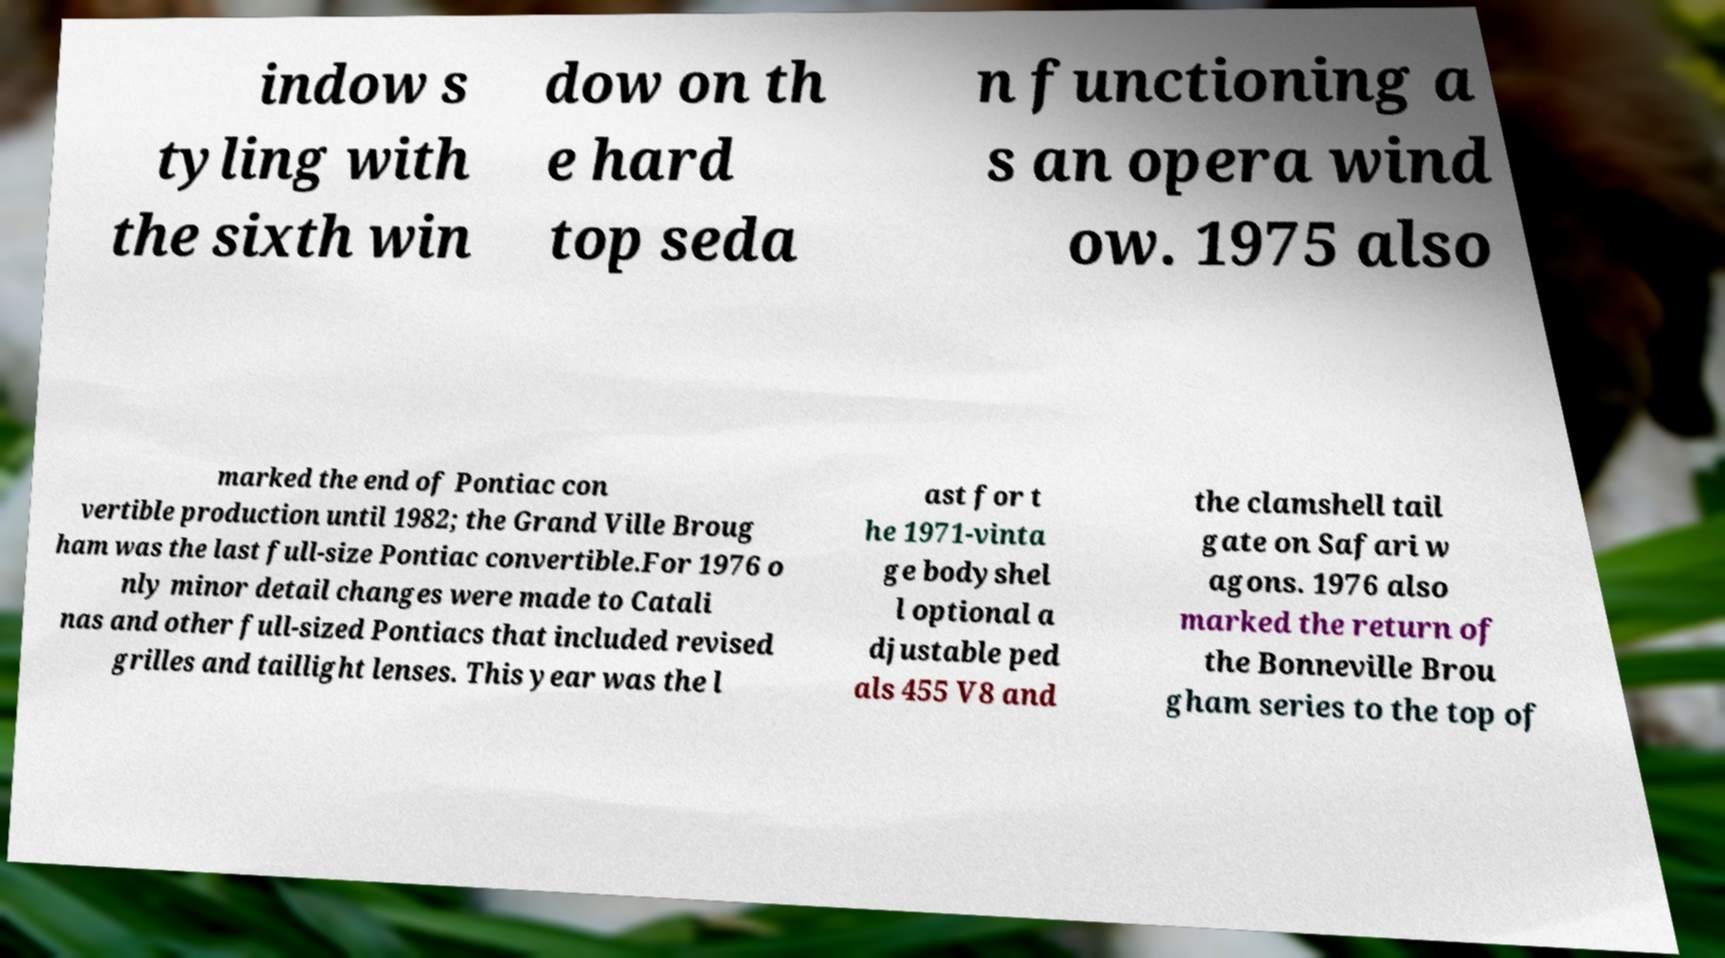I need the written content from this picture converted into text. Can you do that? indow s tyling with the sixth win dow on th e hard top seda n functioning a s an opera wind ow. 1975 also marked the end of Pontiac con vertible production until 1982; the Grand Ville Broug ham was the last full-size Pontiac convertible.For 1976 o nly minor detail changes were made to Catali nas and other full-sized Pontiacs that included revised grilles and taillight lenses. This year was the l ast for t he 1971-vinta ge bodyshel l optional a djustable ped als 455 V8 and the clamshell tail gate on Safari w agons. 1976 also marked the return of the Bonneville Brou gham series to the top of 